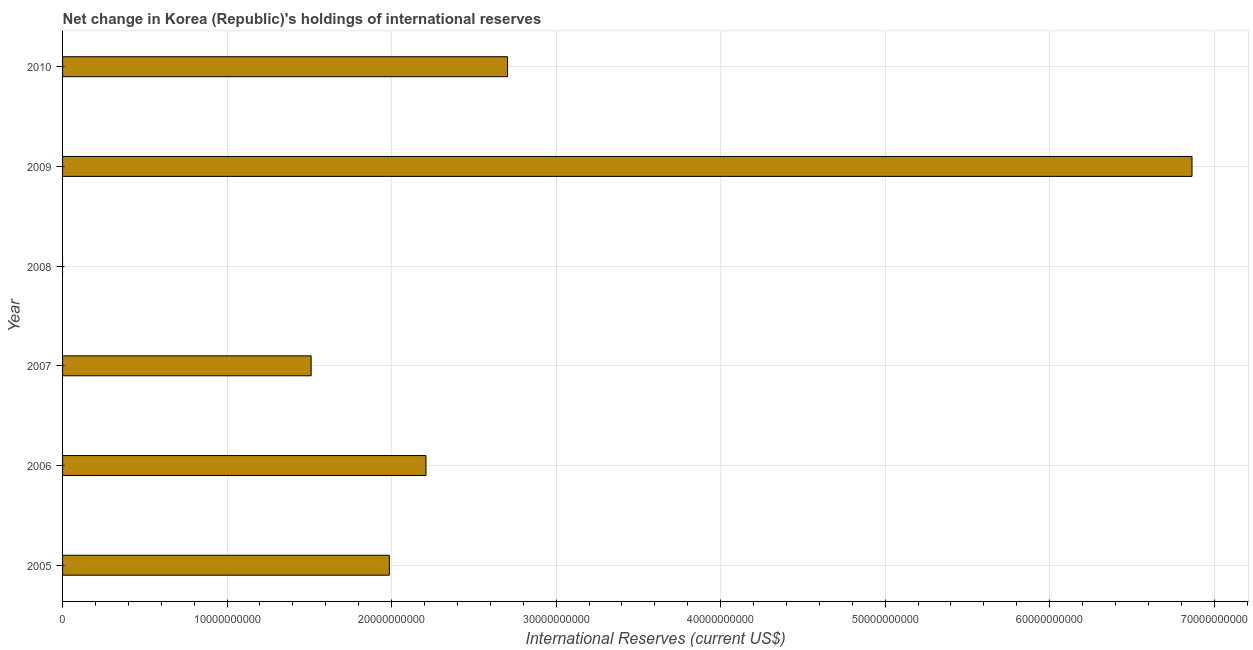Does the graph contain any zero values?
Keep it short and to the point. Yes. Does the graph contain grids?
Provide a succinct answer. Yes. What is the title of the graph?
Make the answer very short. Net change in Korea (Republic)'s holdings of international reserves. What is the label or title of the X-axis?
Give a very brief answer. International Reserves (current US$). What is the reserves and related items in 2008?
Provide a succinct answer. 0. Across all years, what is the maximum reserves and related items?
Make the answer very short. 6.87e+1. What is the sum of the reserves and related items?
Your response must be concise. 1.53e+11. What is the difference between the reserves and related items in 2006 and 2009?
Your answer should be very brief. -4.66e+1. What is the average reserves and related items per year?
Ensure brevity in your answer.  2.55e+1. What is the median reserves and related items?
Your answer should be compact. 2.10e+1. In how many years, is the reserves and related items greater than 58000000000 US$?
Make the answer very short. 1. What is the ratio of the reserves and related items in 2005 to that in 2007?
Give a very brief answer. 1.31. Is the difference between the reserves and related items in 2005 and 2009 greater than the difference between any two years?
Give a very brief answer. No. What is the difference between the highest and the second highest reserves and related items?
Your answer should be compact. 4.16e+1. Is the sum of the reserves and related items in 2006 and 2007 greater than the maximum reserves and related items across all years?
Your answer should be compact. No. What is the difference between the highest and the lowest reserves and related items?
Provide a succinct answer. 6.87e+1. Are all the bars in the graph horizontal?
Keep it short and to the point. Yes. How many years are there in the graph?
Your response must be concise. 6. What is the difference between two consecutive major ticks on the X-axis?
Give a very brief answer. 1.00e+1. What is the International Reserves (current US$) of 2005?
Give a very brief answer. 1.99e+1. What is the International Reserves (current US$) of 2006?
Give a very brief answer. 2.21e+1. What is the International Reserves (current US$) in 2007?
Your answer should be very brief. 1.51e+1. What is the International Reserves (current US$) in 2008?
Make the answer very short. 0. What is the International Reserves (current US$) in 2009?
Offer a terse response. 6.87e+1. What is the International Reserves (current US$) in 2010?
Make the answer very short. 2.70e+1. What is the difference between the International Reserves (current US$) in 2005 and 2006?
Ensure brevity in your answer.  -2.23e+09. What is the difference between the International Reserves (current US$) in 2005 and 2007?
Provide a succinct answer. 4.75e+09. What is the difference between the International Reserves (current US$) in 2005 and 2009?
Your answer should be compact. -4.88e+1. What is the difference between the International Reserves (current US$) in 2005 and 2010?
Ensure brevity in your answer.  -7.18e+09. What is the difference between the International Reserves (current US$) in 2006 and 2007?
Your response must be concise. 6.98e+09. What is the difference between the International Reserves (current US$) in 2006 and 2009?
Your response must be concise. -4.66e+1. What is the difference between the International Reserves (current US$) in 2006 and 2010?
Provide a succinct answer. -4.96e+09. What is the difference between the International Reserves (current US$) in 2007 and 2009?
Ensure brevity in your answer.  -5.35e+1. What is the difference between the International Reserves (current US$) in 2007 and 2010?
Ensure brevity in your answer.  -1.19e+1. What is the difference between the International Reserves (current US$) in 2009 and 2010?
Your response must be concise. 4.16e+1. What is the ratio of the International Reserves (current US$) in 2005 to that in 2006?
Your response must be concise. 0.9. What is the ratio of the International Reserves (current US$) in 2005 to that in 2007?
Your response must be concise. 1.31. What is the ratio of the International Reserves (current US$) in 2005 to that in 2009?
Offer a terse response. 0.29. What is the ratio of the International Reserves (current US$) in 2005 to that in 2010?
Give a very brief answer. 0.73. What is the ratio of the International Reserves (current US$) in 2006 to that in 2007?
Provide a short and direct response. 1.46. What is the ratio of the International Reserves (current US$) in 2006 to that in 2009?
Give a very brief answer. 0.32. What is the ratio of the International Reserves (current US$) in 2006 to that in 2010?
Provide a succinct answer. 0.82. What is the ratio of the International Reserves (current US$) in 2007 to that in 2009?
Offer a terse response. 0.22. What is the ratio of the International Reserves (current US$) in 2007 to that in 2010?
Offer a very short reply. 0.56. What is the ratio of the International Reserves (current US$) in 2009 to that in 2010?
Your answer should be compact. 2.54. 